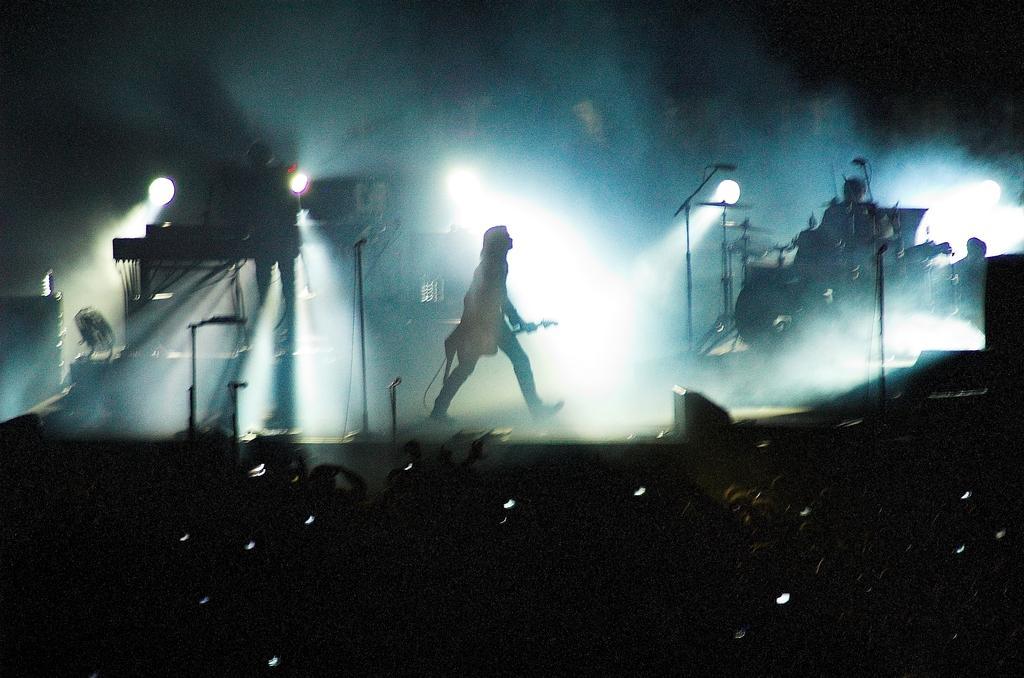Please provide a concise description of this image. Here we can see a person, mike's, lights, and musical instruments. There are group of people and there is a dark background. 